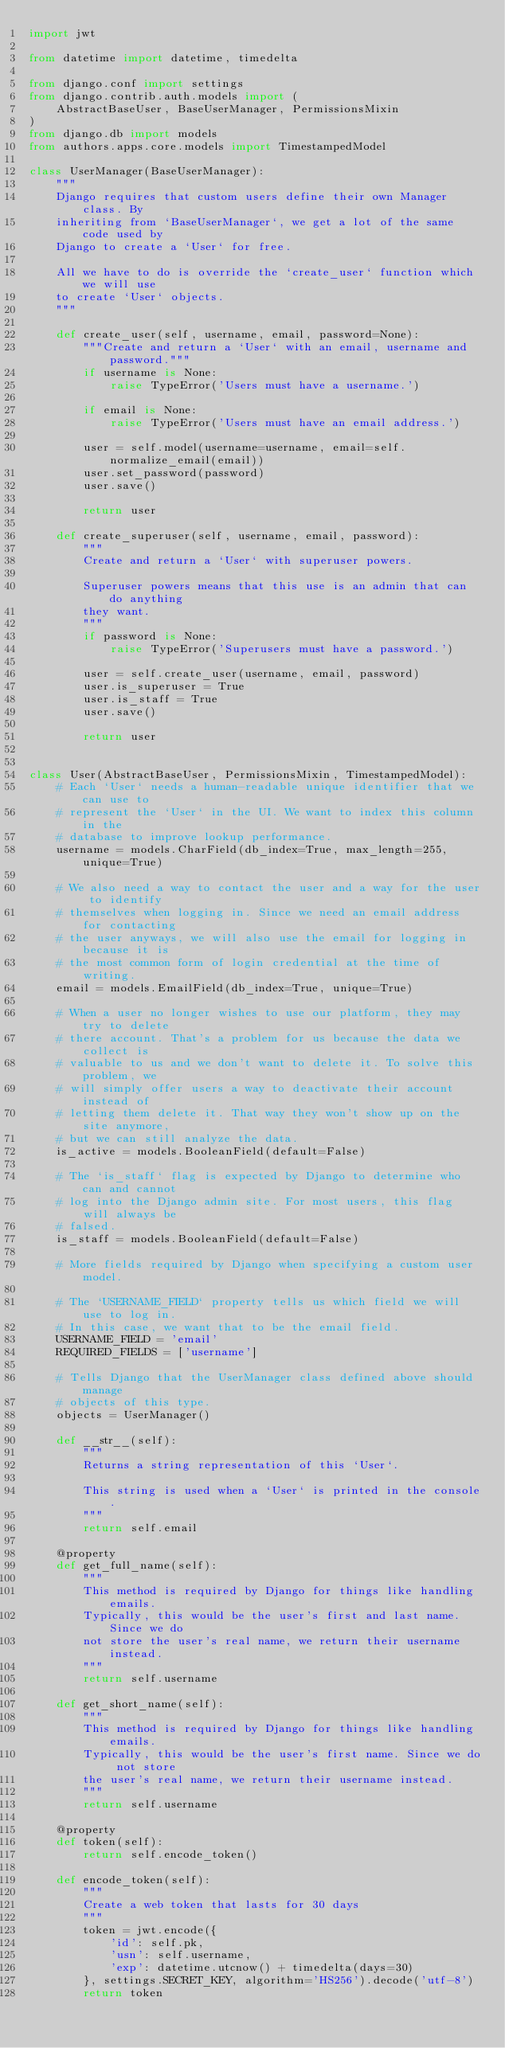<code> <loc_0><loc_0><loc_500><loc_500><_Python_>import jwt

from datetime import datetime, timedelta

from django.conf import settings
from django.contrib.auth.models import (
    AbstractBaseUser, BaseUserManager, PermissionsMixin
)
from django.db import models
from authors.apps.core.models import TimestampedModel

class UserManager(BaseUserManager):
    """
    Django requires that custom users define their own Manager class. By
    inheriting from `BaseUserManager`, we get a lot of the same code used by
    Django to create a `User` for free.

    All we have to do is override the `create_user` function which we will use
    to create `User` objects.
    """

    def create_user(self, username, email, password=None):
        """Create and return a `User` with an email, username and password."""
        if username is None:
            raise TypeError('Users must have a username.')

        if email is None:
            raise TypeError('Users must have an email address.')

        user = self.model(username=username, email=self.normalize_email(email))
        user.set_password(password)
        user.save()

        return user

    def create_superuser(self, username, email, password):
        """
        Create and return a `User` with superuser powers.

        Superuser powers means that this use is an admin that can do anything
        they want.
        """
        if password is None:
            raise TypeError('Superusers must have a password.')

        user = self.create_user(username, email, password)
        user.is_superuser = True
        user.is_staff = True
        user.save()

        return user


class User(AbstractBaseUser, PermissionsMixin, TimestampedModel):
    # Each `User` needs a human-readable unique identifier that we can use to
    # represent the `User` in the UI. We want to index this column in the
    # database to improve lookup performance.
    username = models.CharField(db_index=True, max_length=255, unique=True)

    # We also need a way to contact the user and a way for the user to identify
    # themselves when logging in. Since we need an email address for contacting
    # the user anyways, we will also use the email for logging in because it is
    # the most common form of login credential at the time of writing.
    email = models.EmailField(db_index=True, unique=True)

    # When a user no longer wishes to use our platform, they may try to delete
    # there account. That's a problem for us because the data we collect is
    # valuable to us and we don't want to delete it. To solve this problem, we
    # will simply offer users a way to deactivate their account instead of
    # letting them delete it. That way they won't show up on the site anymore,
    # but we can still analyze the data.
    is_active = models.BooleanField(default=False)

    # The `is_staff` flag is expected by Django to determine who can and cannot
    # log into the Django admin site. For most users, this flag will always be
    # falsed.
    is_staff = models.BooleanField(default=False)

    # More fields required by Django when specifying a custom user model.

    # The `USERNAME_FIELD` property tells us which field we will use to log in.
    # In this case, we want that to be the email field.
    USERNAME_FIELD = 'email'
    REQUIRED_FIELDS = ['username']

    # Tells Django that the UserManager class defined above should manage
    # objects of this type.
    objects = UserManager()

    def __str__(self):
        """
        Returns a string representation of this `User`.

        This string is used when a `User` is printed in the console.
        """
        return self.email

    @property
    def get_full_name(self):
        """
        This method is required by Django for things like handling emails.
        Typically, this would be the user's first and last name. Since we do
        not store the user's real name, we return their username instead.
        """
        return self.username

    def get_short_name(self):
        """
        This method is required by Django for things like handling emails.
        Typically, this would be the user's first name. Since we do not store
        the user's real name, we return their username instead.
        """
        return self.username

    @property
    def token(self):
        return self.encode_token()

    def encode_token(self):
        """
        Create a web token that lasts for 30 days
        """
        token = jwt.encode({
            'id': self.pk,
            'usn': self.username,
            'exp': datetime.utcnow() + timedelta(days=30)
        }, settings.SECRET_KEY, algorithm='HS256').decode('utf-8')
        return token
</code> 